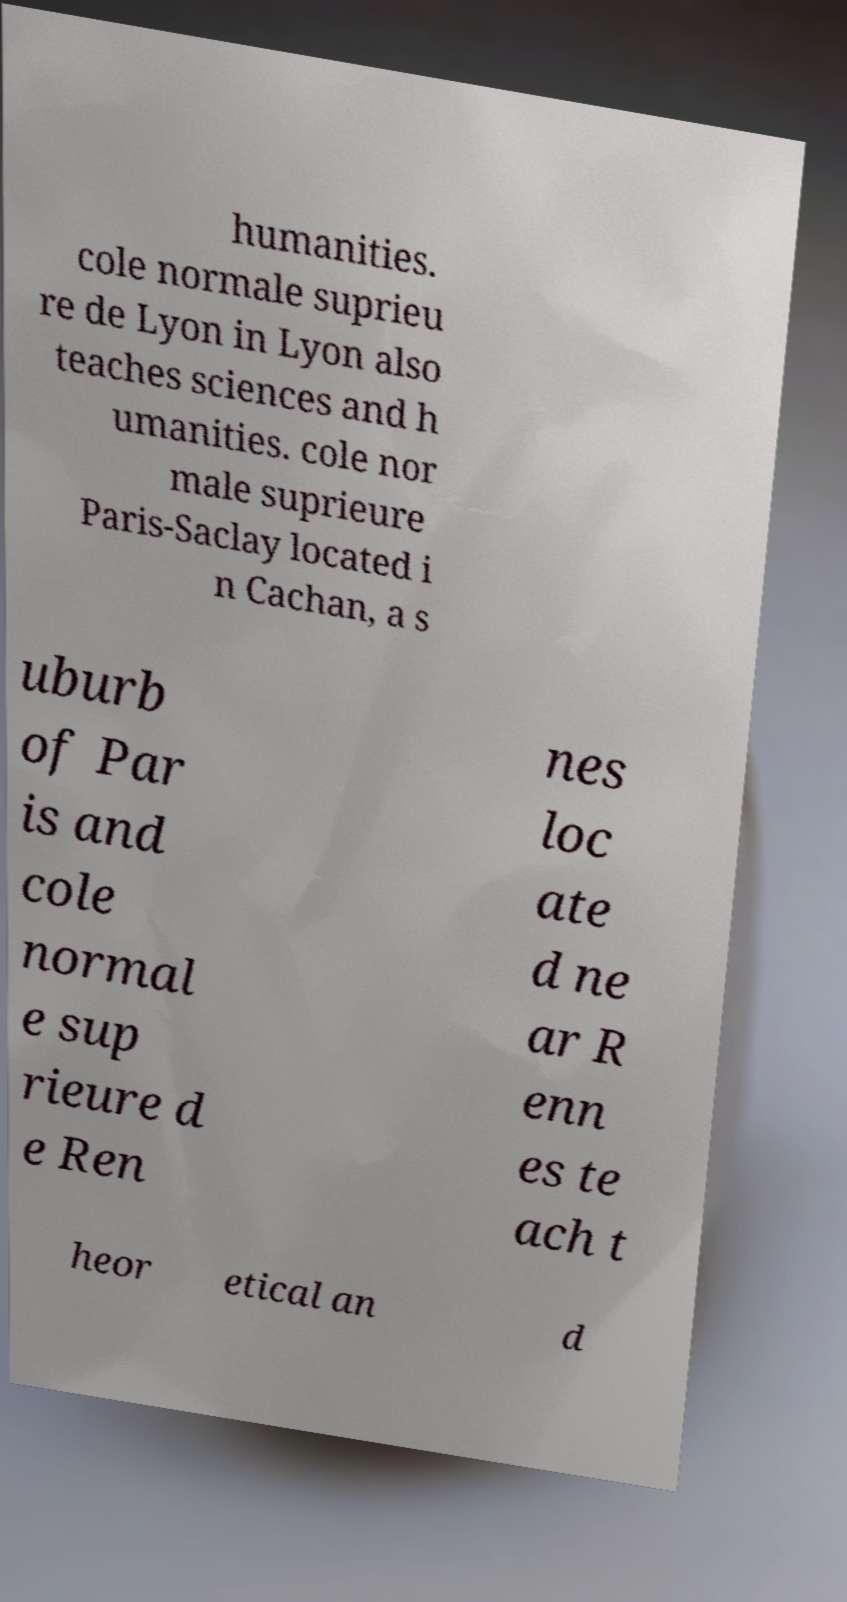Can you accurately transcribe the text from the provided image for me? humanities. cole normale suprieu re de Lyon in Lyon also teaches sciences and h umanities. cole nor male suprieure Paris-Saclay located i n Cachan, a s uburb of Par is and cole normal e sup rieure d e Ren nes loc ate d ne ar R enn es te ach t heor etical an d 